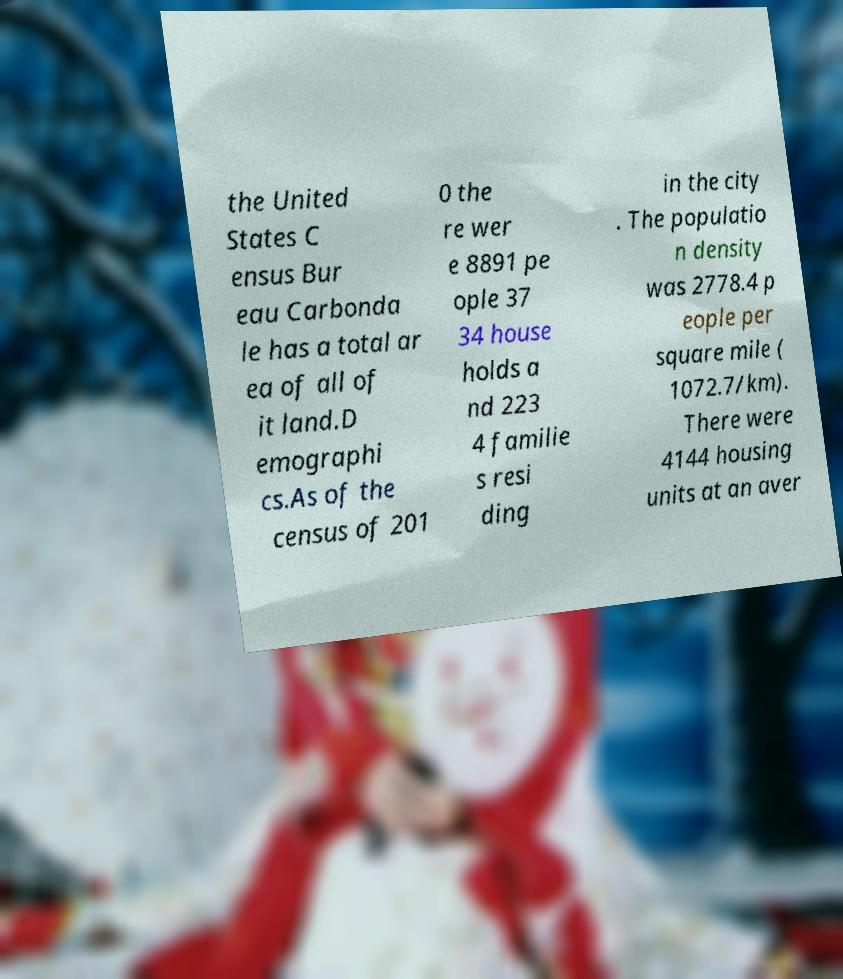Can you accurately transcribe the text from the provided image for me? the United States C ensus Bur eau Carbonda le has a total ar ea of all of it land.D emographi cs.As of the census of 201 0 the re wer e 8891 pe ople 37 34 house holds a nd 223 4 familie s resi ding in the city . The populatio n density was 2778.4 p eople per square mile ( 1072.7/km). There were 4144 housing units at an aver 